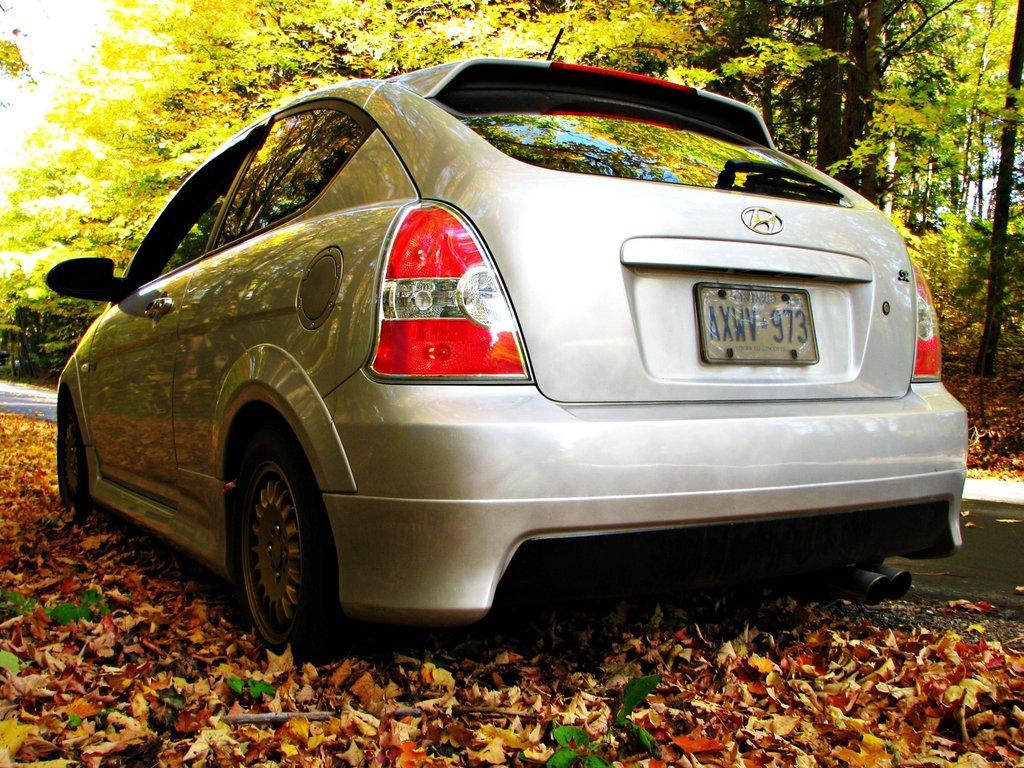In one or two sentences, can you explain what this image depicts? In this image in the center there is one car, and in the background there are some trees. At the bottom there are some leaves and walkway. 